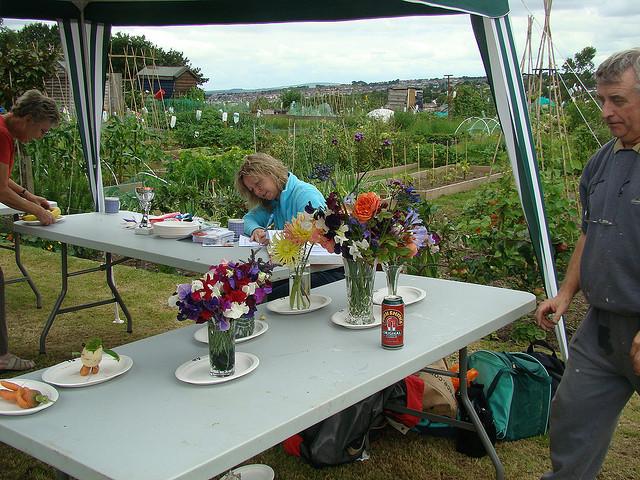Are one of the men wearing eyeglasses?
Be succinct. No. Is there someone sleeping on the top part of the picnic table?
Write a very short answer. No. How many different types of flowers do you notice?
Short answer required. 10. How many vases are on the table?
Be succinct. 5. Are there any condiments?
Answer briefly. No. How many tables are there?
Concise answer only. 2. 